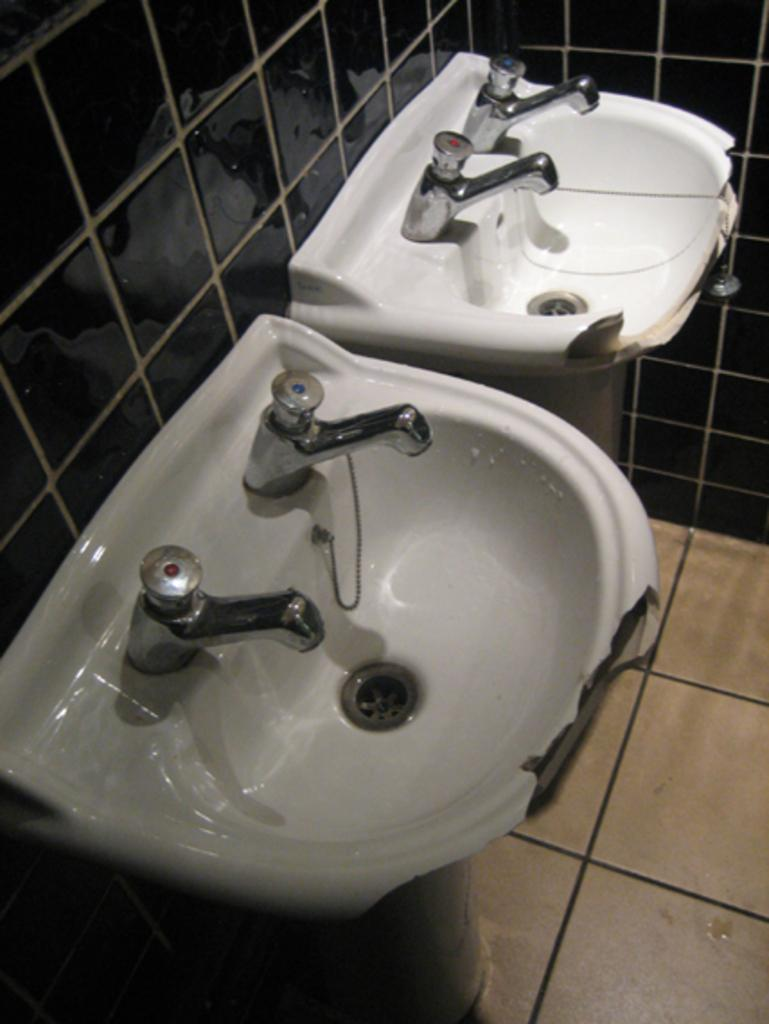How many wash basins are present in the image? There are two wash basins in the image. What is associated with the wash basins? There are taps associated with the wash basins. What is the wall surface made of in the image? The wall in the image is tiled. What can be seen below the wash basins in the image? The floor is visible in the image. What type of cake is being taught during recess in the image? There is no cake or teaching activity present in the image. 